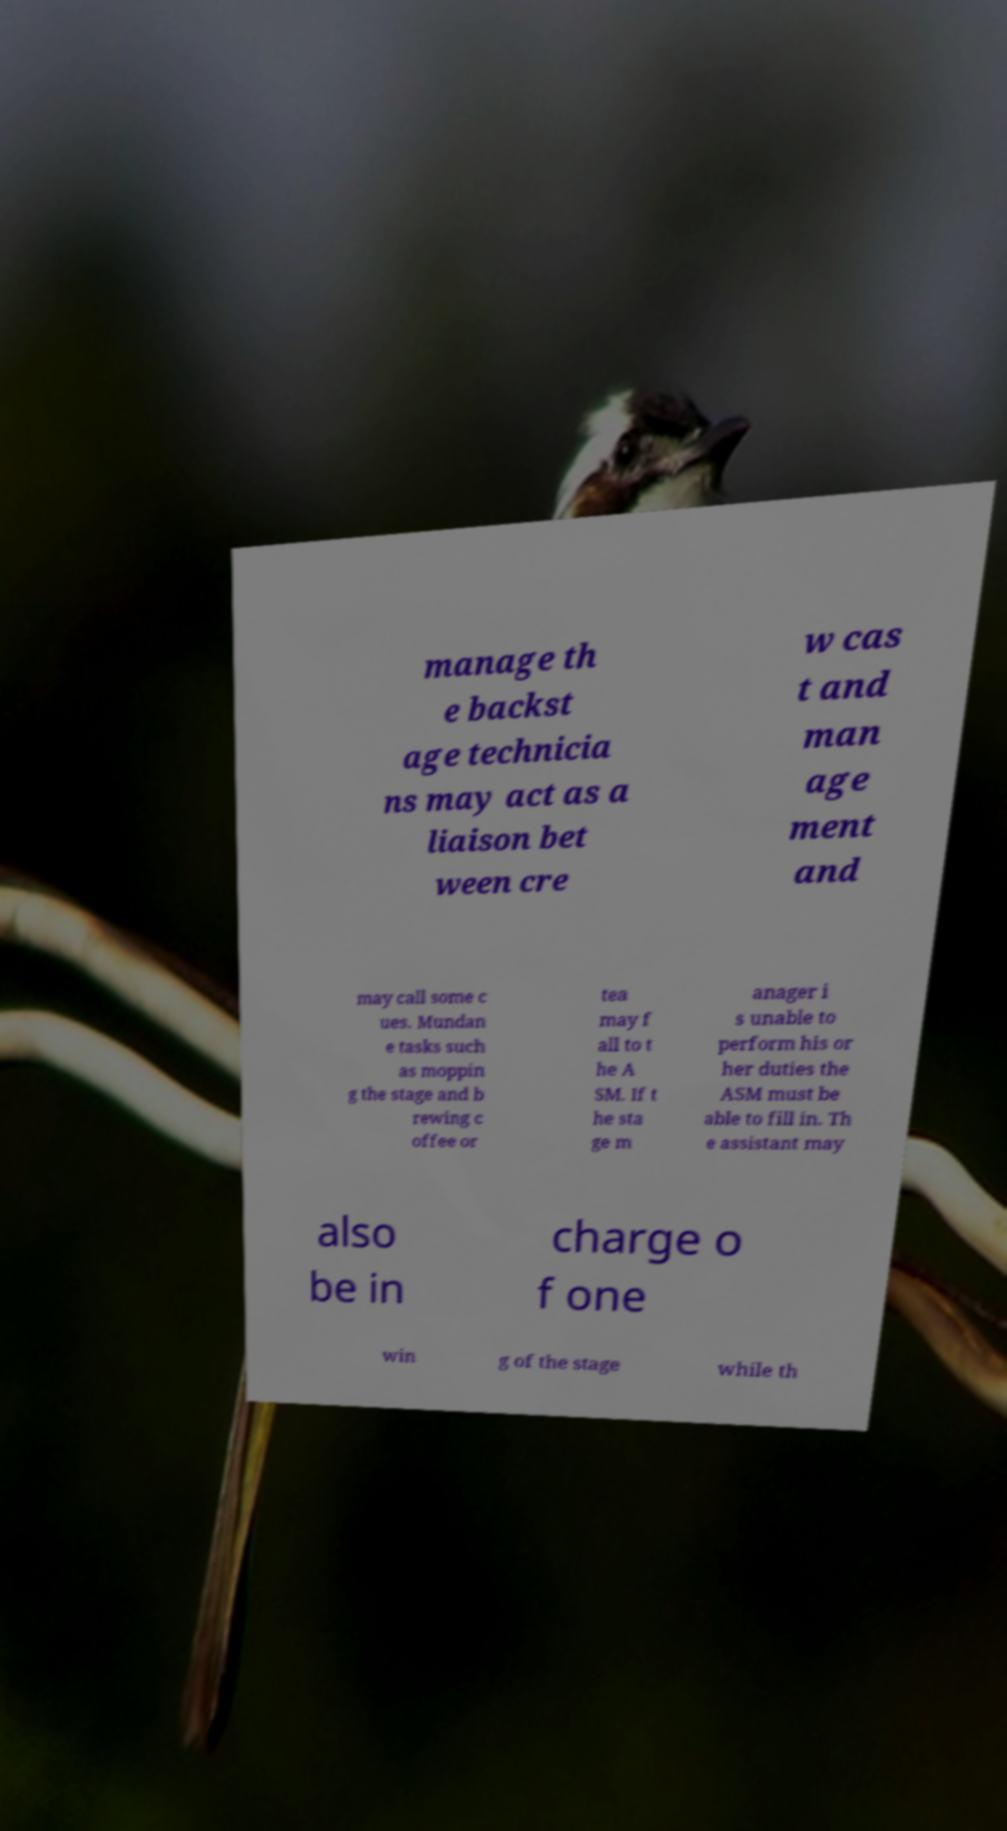Could you extract and type out the text from this image? manage th e backst age technicia ns may act as a liaison bet ween cre w cas t and man age ment and may call some c ues. Mundan e tasks such as moppin g the stage and b rewing c offee or tea may f all to t he A SM. If t he sta ge m anager i s unable to perform his or her duties the ASM must be able to fill in. Th e assistant may also be in charge o f one win g of the stage while th 